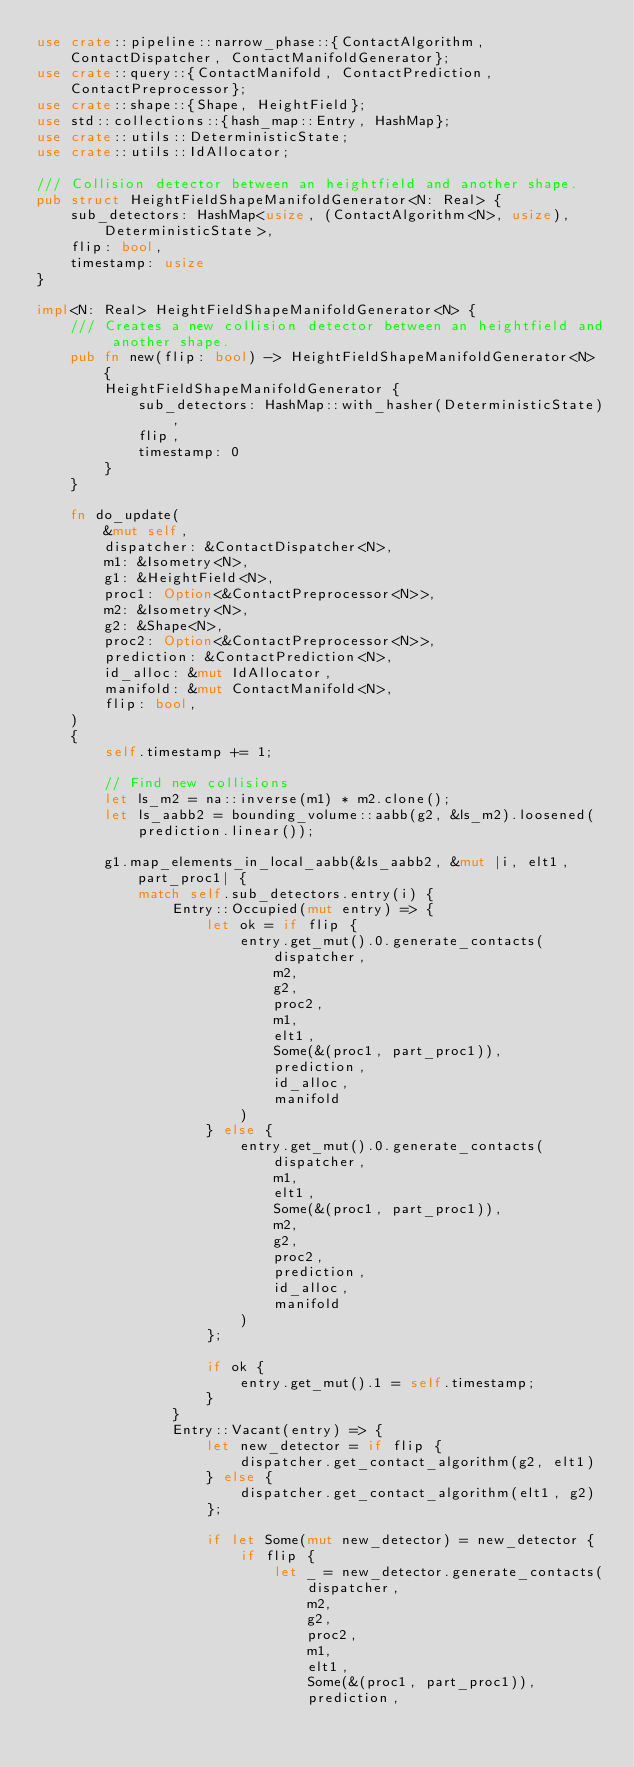<code> <loc_0><loc_0><loc_500><loc_500><_Rust_>use crate::pipeline::narrow_phase::{ContactAlgorithm, ContactDispatcher, ContactManifoldGenerator};
use crate::query::{ContactManifold, ContactPrediction, ContactPreprocessor};
use crate::shape::{Shape, HeightField};
use std::collections::{hash_map::Entry, HashMap};
use crate::utils::DeterministicState;
use crate::utils::IdAllocator;

/// Collision detector between an heightfield and another shape.
pub struct HeightFieldShapeManifoldGenerator<N: Real> {
    sub_detectors: HashMap<usize, (ContactAlgorithm<N>, usize), DeterministicState>,
    flip: bool,
    timestamp: usize
}

impl<N: Real> HeightFieldShapeManifoldGenerator<N> {
    /// Creates a new collision detector between an heightfield and another shape.
    pub fn new(flip: bool) -> HeightFieldShapeManifoldGenerator<N> {
        HeightFieldShapeManifoldGenerator {
            sub_detectors: HashMap::with_hasher(DeterministicState),
            flip,
            timestamp: 0
        }
    }

    fn do_update(
        &mut self,
        dispatcher: &ContactDispatcher<N>,
        m1: &Isometry<N>,
        g1: &HeightField<N>,
        proc1: Option<&ContactPreprocessor<N>>,
        m2: &Isometry<N>,
        g2: &Shape<N>,
        proc2: Option<&ContactPreprocessor<N>>,
        prediction: &ContactPrediction<N>,
        id_alloc: &mut IdAllocator,
        manifold: &mut ContactManifold<N>,
        flip: bool,
    )
    {
        self.timestamp += 1;

        // Find new collisions
        let ls_m2 = na::inverse(m1) * m2.clone();
        let ls_aabb2 = bounding_volume::aabb(g2, &ls_m2).loosened(prediction.linear());

        g1.map_elements_in_local_aabb(&ls_aabb2, &mut |i, elt1, part_proc1| {
            match self.sub_detectors.entry(i) {
                Entry::Occupied(mut entry) => {
                    let ok = if flip {
                        entry.get_mut().0.generate_contacts(
                            dispatcher,
                            m2,
                            g2,
                            proc2,
                            m1,
                            elt1,
                            Some(&(proc1, part_proc1)),
                            prediction,
                            id_alloc,
                            manifold
                        )
                    } else {
                        entry.get_mut().0.generate_contacts(
                            dispatcher,
                            m1,
                            elt1,
                            Some(&(proc1, part_proc1)),
                            m2,
                            g2,
                            proc2,
                            prediction,
                            id_alloc,
                            manifold
                        )
                    };

                    if ok {
                        entry.get_mut().1 = self.timestamp;
                    }
                }
                Entry::Vacant(entry) => {
                    let new_detector = if flip {
                        dispatcher.get_contact_algorithm(g2, elt1)
                    } else {
                        dispatcher.get_contact_algorithm(elt1, g2)
                    };

                    if let Some(mut new_detector) = new_detector {
                        if flip {
                            let _ = new_detector.generate_contacts(
                                dispatcher,
                                m2,
                                g2,
                                proc2,
                                m1,
                                elt1,
                                Some(&(proc1, part_proc1)),
                                prediction,</code> 